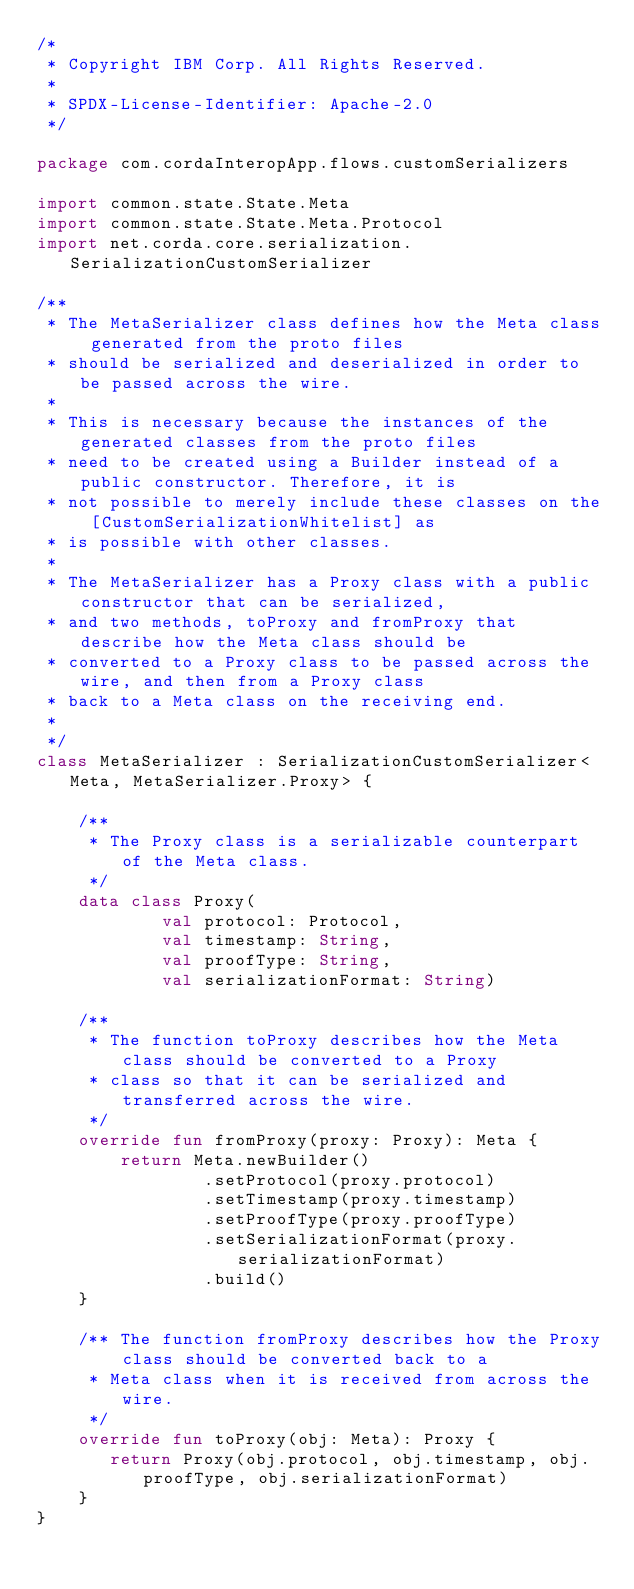Convert code to text. <code><loc_0><loc_0><loc_500><loc_500><_Kotlin_>/*
 * Copyright IBM Corp. All Rights Reserved.
 *
 * SPDX-License-Identifier: Apache-2.0
 */

package com.cordaInteropApp.flows.customSerializers

import common.state.State.Meta
import common.state.State.Meta.Protocol
import net.corda.core.serialization.SerializationCustomSerializer

/**
 * The MetaSerializer class defines how the Meta class generated from the proto files
 * should be serialized and deserialized in order to be passed across the wire.
 *
 * This is necessary because the instances of the generated classes from the proto files
 * need to be created using a Builder instead of a public constructor. Therefore, it is
 * not possible to merely include these classes on the [CustomSerializationWhitelist] as
 * is possible with other classes.
 *
 * The MetaSerializer has a Proxy class with a public constructor that can be serialized,
 * and two methods, toProxy and fromProxy that describe how the Meta class should be
 * converted to a Proxy class to be passed across the wire, and then from a Proxy class
 * back to a Meta class on the receiving end.
 *
 */
class MetaSerializer : SerializationCustomSerializer<Meta, MetaSerializer.Proxy> {

    /**
     * The Proxy class is a serializable counterpart of the Meta class.
     */
    data class Proxy(
            val protocol: Protocol,
            val timestamp: String,
            val proofType: String,
            val serializationFormat: String)

    /**
     * The function toProxy describes how the Meta class should be converted to a Proxy
     * class so that it can be serialized and transferred across the wire.
     */
    override fun fromProxy(proxy: Proxy): Meta {
        return Meta.newBuilder()
                .setProtocol(proxy.protocol)
                .setTimestamp(proxy.timestamp)
                .setProofType(proxy.proofType)
                .setSerializationFormat(proxy.serializationFormat)
                .build()
    }

    /** The function fromProxy describes how the Proxy class should be converted back to a
     * Meta class when it is received from across the wire.
     */
    override fun toProxy(obj: Meta): Proxy {
       return Proxy(obj.protocol, obj.timestamp, obj.proofType, obj.serializationFormat)
    }
}
</code> 